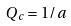<formula> <loc_0><loc_0><loc_500><loc_500>Q _ { c } = 1 / a</formula> 